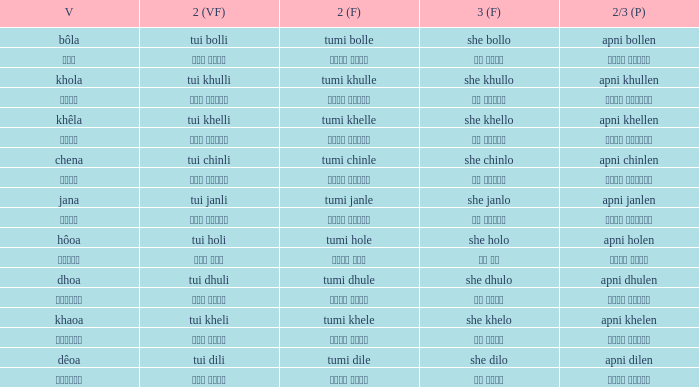What is the 2nd verb for Khola? Tumi khulle. Help me parse the entirety of this table. {'header': ['V', '2 (VF)', '2 (F)', '3 (F)', '2/3 (P)'], 'rows': [['bôla', 'tui bolli', 'tumi bolle', 'she bollo', 'apni bollen'], ['বলা', 'তুই বললি', 'তুমি বললে', 'সে বললো', 'আপনি বললেন'], ['khola', 'tui khulli', 'tumi khulle', 'she khullo', 'apni khullen'], ['খোলা', 'তুই খুললি', 'তুমি খুললে', 'সে খুললো', 'আপনি খুললেন'], ['khêla', 'tui khelli', 'tumi khelle', 'she khello', 'apni khellen'], ['খেলে', 'তুই খেললি', 'তুমি খেললে', 'সে খেললো', 'আপনি খেললেন'], ['chena', 'tui chinli', 'tumi chinle', 'she chinlo', 'apni chinlen'], ['চেনা', 'তুই চিনলি', 'তুমি চিনলে', 'সে চিনলো', 'আপনি চিনলেন'], ['jana', 'tui janli', 'tumi janle', 'she janlo', 'apni janlen'], ['জানা', 'তুই জানলি', 'তুমি জানলে', 'সে জানলে', 'আপনি জানলেন'], ['hôoa', 'tui holi', 'tumi hole', 'she holo', 'apni holen'], ['হওয়া', 'তুই হলি', 'তুমি হলে', 'সে হল', 'আপনি হলেন'], ['dhoa', 'tui dhuli', 'tumi dhule', 'she dhulo', 'apni dhulen'], ['ধোওয়া', 'তুই ধুলি', 'তুমি ধুলে', 'সে ধুলো', 'আপনি ধুলেন'], ['khaoa', 'tui kheli', 'tumi khele', 'she khelo', 'apni khelen'], ['খাওয়া', 'তুই খেলি', 'তুমি খেলে', 'সে খেলো', 'আপনি খেলেন'], ['dêoa', 'tui dili', 'tumi dile', 'she dilo', 'apni dilen'], ['দেওয়া', 'তুই দিলি', 'তুমি দিলে', 'সে দিলো', 'আপনি দিলেন']]} 